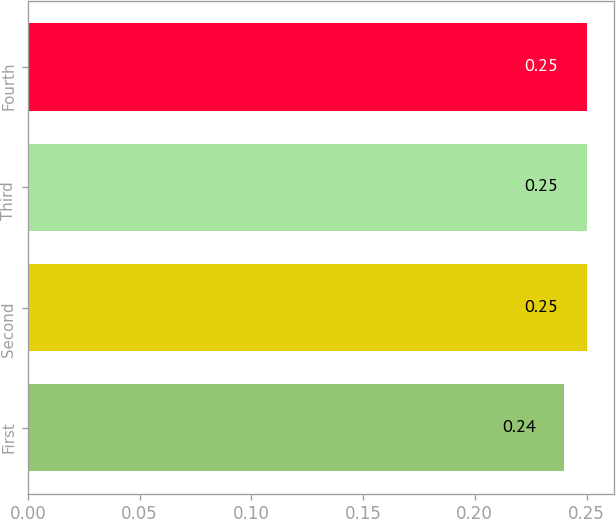Convert chart. <chart><loc_0><loc_0><loc_500><loc_500><bar_chart><fcel>First<fcel>Second<fcel>Third<fcel>Fourth<nl><fcel>0.24<fcel>0.25<fcel>0.25<fcel>0.25<nl></chart> 